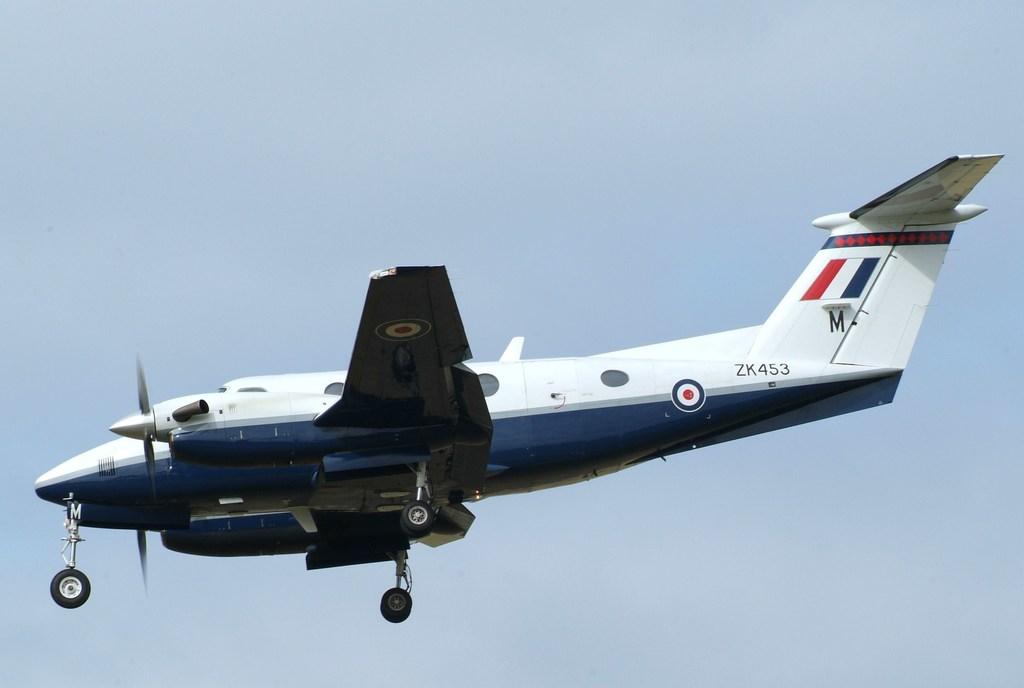What is the call sign of the plane?
Make the answer very short. Zk453. What letter is written on the plane at the end?
Ensure brevity in your answer.  M. 